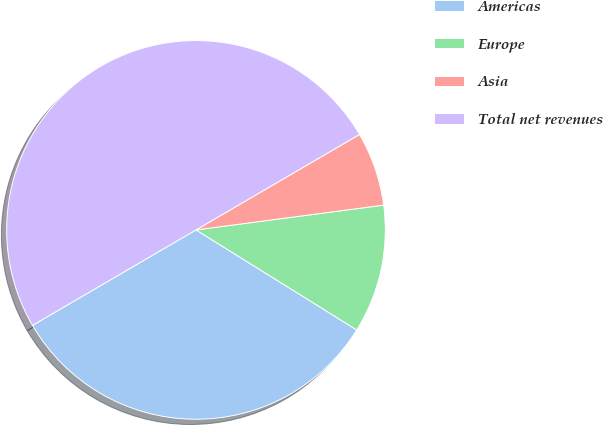Convert chart to OTSL. <chart><loc_0><loc_0><loc_500><loc_500><pie_chart><fcel>Americas<fcel>Europe<fcel>Asia<fcel>Total net revenues<nl><fcel>32.73%<fcel>10.95%<fcel>6.32%<fcel>50.0%<nl></chart> 